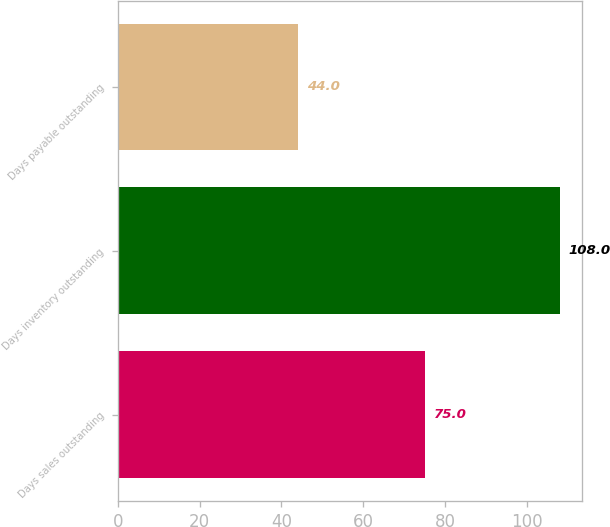Convert chart to OTSL. <chart><loc_0><loc_0><loc_500><loc_500><bar_chart><fcel>Days sales outstanding<fcel>Days inventory outstanding<fcel>Days payable outstanding<nl><fcel>75<fcel>108<fcel>44<nl></chart> 